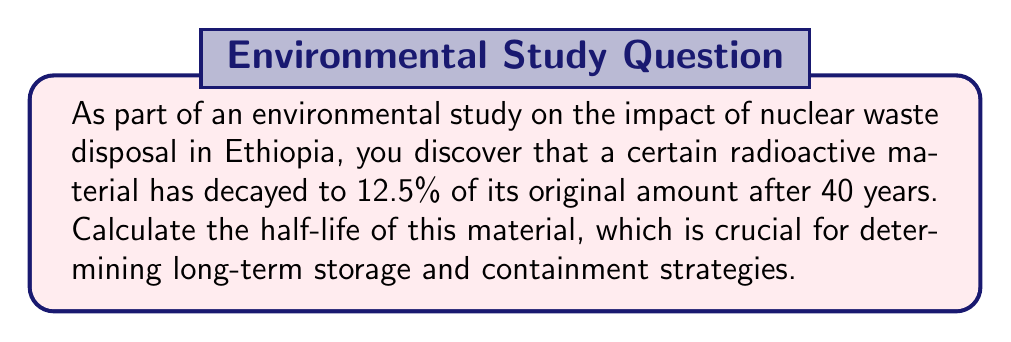Show me your answer to this math problem. To solve this problem, we'll use the exponential decay formula and properties of logarithms:

1) The general form of exponential decay is:
   $A(t) = A_0 \cdot (1/2)^{t/t_{1/2}}$
   Where $A(t)$ is the amount at time $t$, $A_0$ is the initial amount, and $t_{1/2}$ is the half-life.

2) We know that after 40 years, 12.5% of the original amount remains. So:
   $0.125 = (1/2)^{40/t_{1/2}}$

3) Taking the logarithm of both sides:
   $\log(0.125) = \log((1/2)^{40/t_{1/2}})$

4) Using the power property of logarithms:
   $\log(0.125) = (40/t_{1/2}) \cdot \log(1/2)$

5) We know that $\log(1/2) = -\log(2)$, so:
   $\log(0.125) = -(40/t_{1/2}) \cdot \log(2)$

6) We also know that $0.125 = 1/8 = 2^{-3}$, so $\log(0.125) = -3\log(2)$

7) Substituting this in:
   $-3\log(2) = -(40/t_{1/2}) \cdot \log(2)$

8) Cancelling $\log(2)$ from both sides:
   $-3 = -40/t_{1/2}$

9) Solving for $t_{1/2}$:
   $t_{1/2} = 40/3 \approx 13.33$ years

Therefore, the half-life of the radioactive material is approximately 13.33 years.
Answer: 13.33 years 